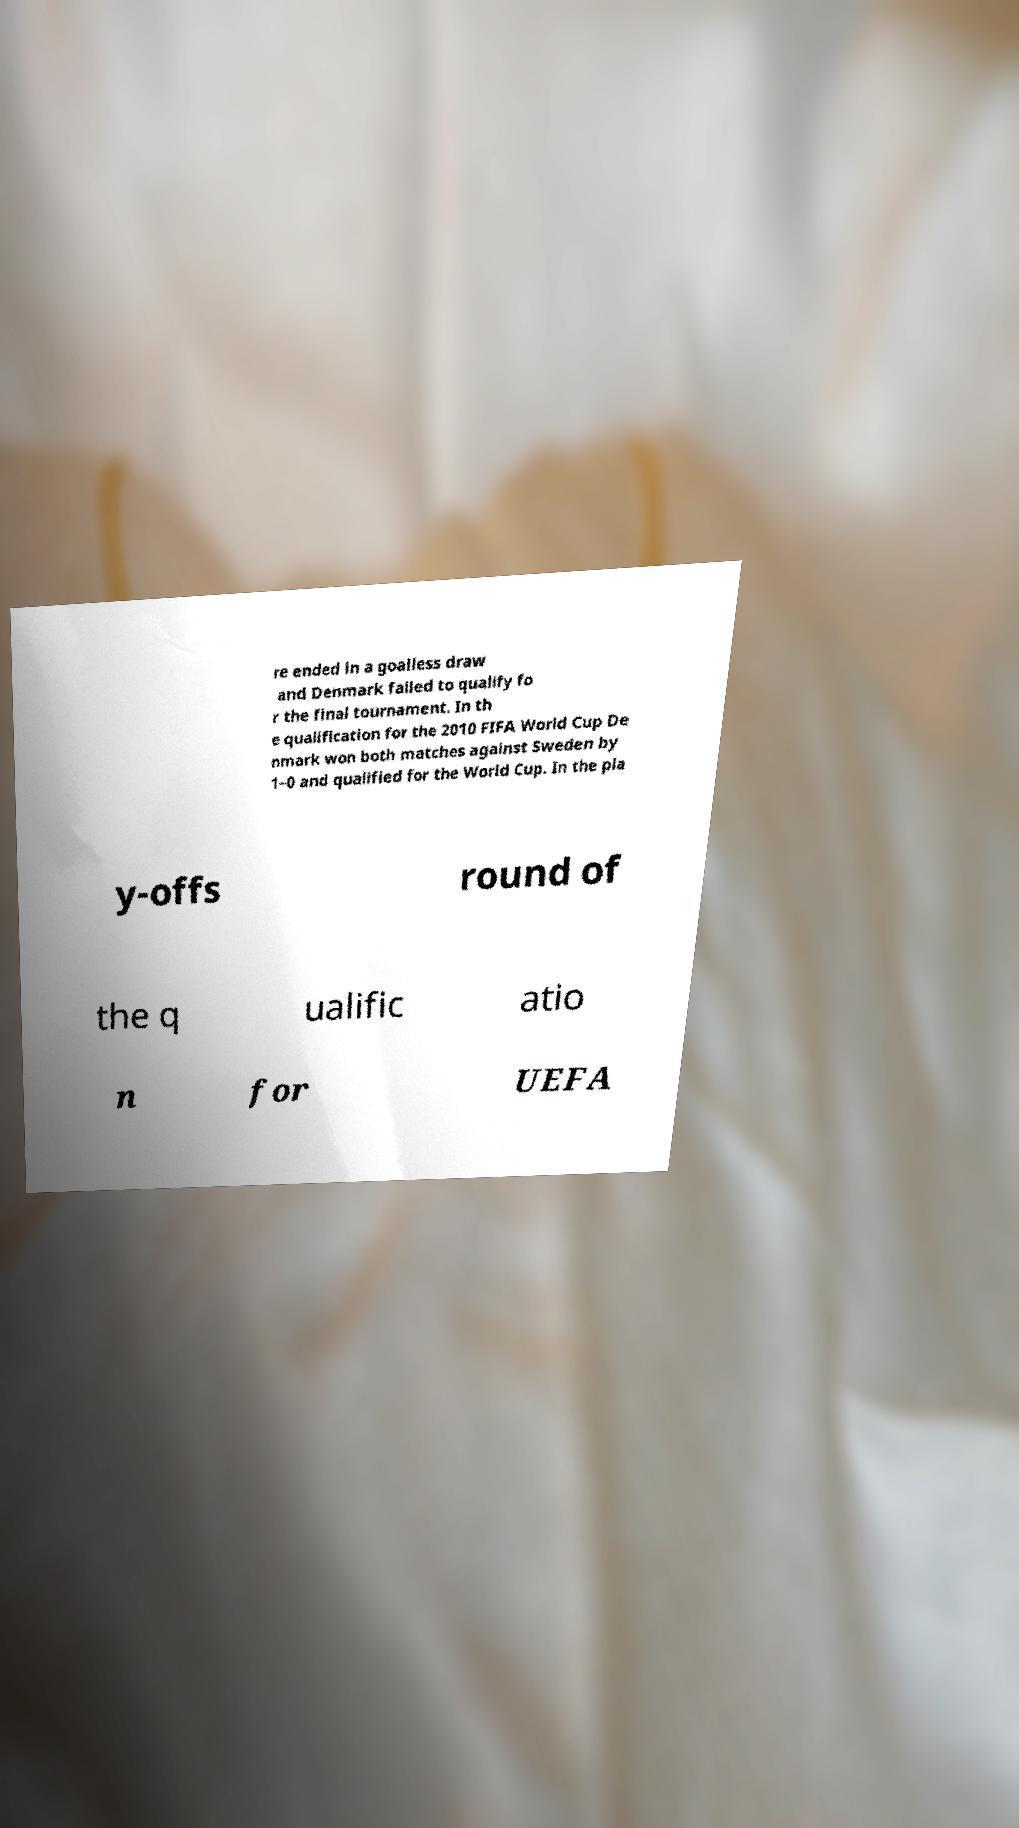Could you extract and type out the text from this image? re ended in a goalless draw and Denmark failed to qualify fo r the final tournament. In th e qualification for the 2010 FIFA World Cup De nmark won both matches against Sweden by 1–0 and qualified for the World Cup. In the pla y-offs round of the q ualific atio n for UEFA 